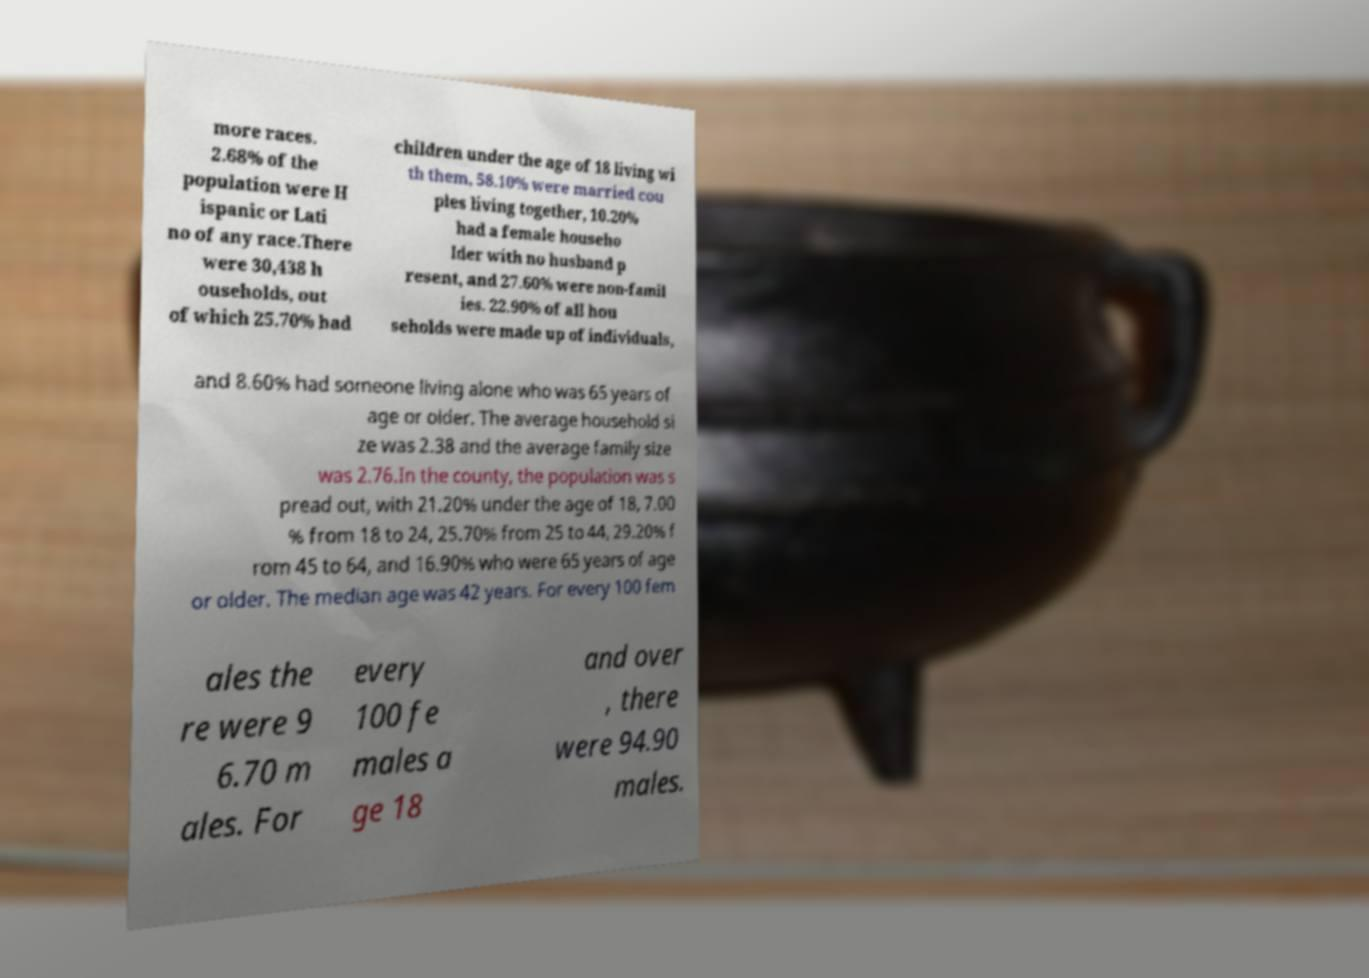Can you accurately transcribe the text from the provided image for me? more races. 2.68% of the population were H ispanic or Lati no of any race.There were 30,438 h ouseholds, out of which 25.70% had children under the age of 18 living wi th them, 58.10% were married cou ples living together, 10.20% had a female househo lder with no husband p resent, and 27.60% were non-famil ies. 22.90% of all hou seholds were made up of individuals, and 8.60% had someone living alone who was 65 years of age or older. The average household si ze was 2.38 and the average family size was 2.76.In the county, the population was s pread out, with 21.20% under the age of 18, 7.00 % from 18 to 24, 25.70% from 25 to 44, 29.20% f rom 45 to 64, and 16.90% who were 65 years of age or older. The median age was 42 years. For every 100 fem ales the re were 9 6.70 m ales. For every 100 fe males a ge 18 and over , there were 94.90 males. 